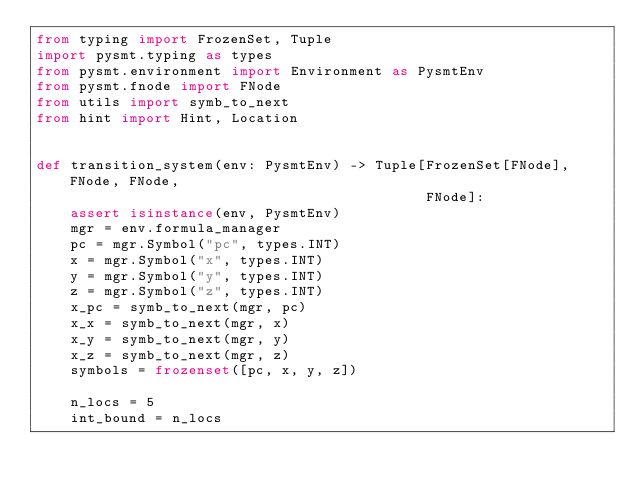<code> <loc_0><loc_0><loc_500><loc_500><_Python_>from typing import FrozenSet, Tuple
import pysmt.typing as types
from pysmt.environment import Environment as PysmtEnv
from pysmt.fnode import FNode
from utils import symb_to_next
from hint import Hint, Location


def transition_system(env: PysmtEnv) -> Tuple[FrozenSet[FNode], FNode, FNode,
                                              FNode]:
    assert isinstance(env, PysmtEnv)
    mgr = env.formula_manager
    pc = mgr.Symbol("pc", types.INT)
    x = mgr.Symbol("x", types.INT)
    y = mgr.Symbol("y", types.INT)
    z = mgr.Symbol("z", types.INT)
    x_pc = symb_to_next(mgr, pc)
    x_x = symb_to_next(mgr, x)
    x_y = symb_to_next(mgr, y)
    x_z = symb_to_next(mgr, z)
    symbols = frozenset([pc, x, y, z])

    n_locs = 5
    int_bound = n_locs</code> 